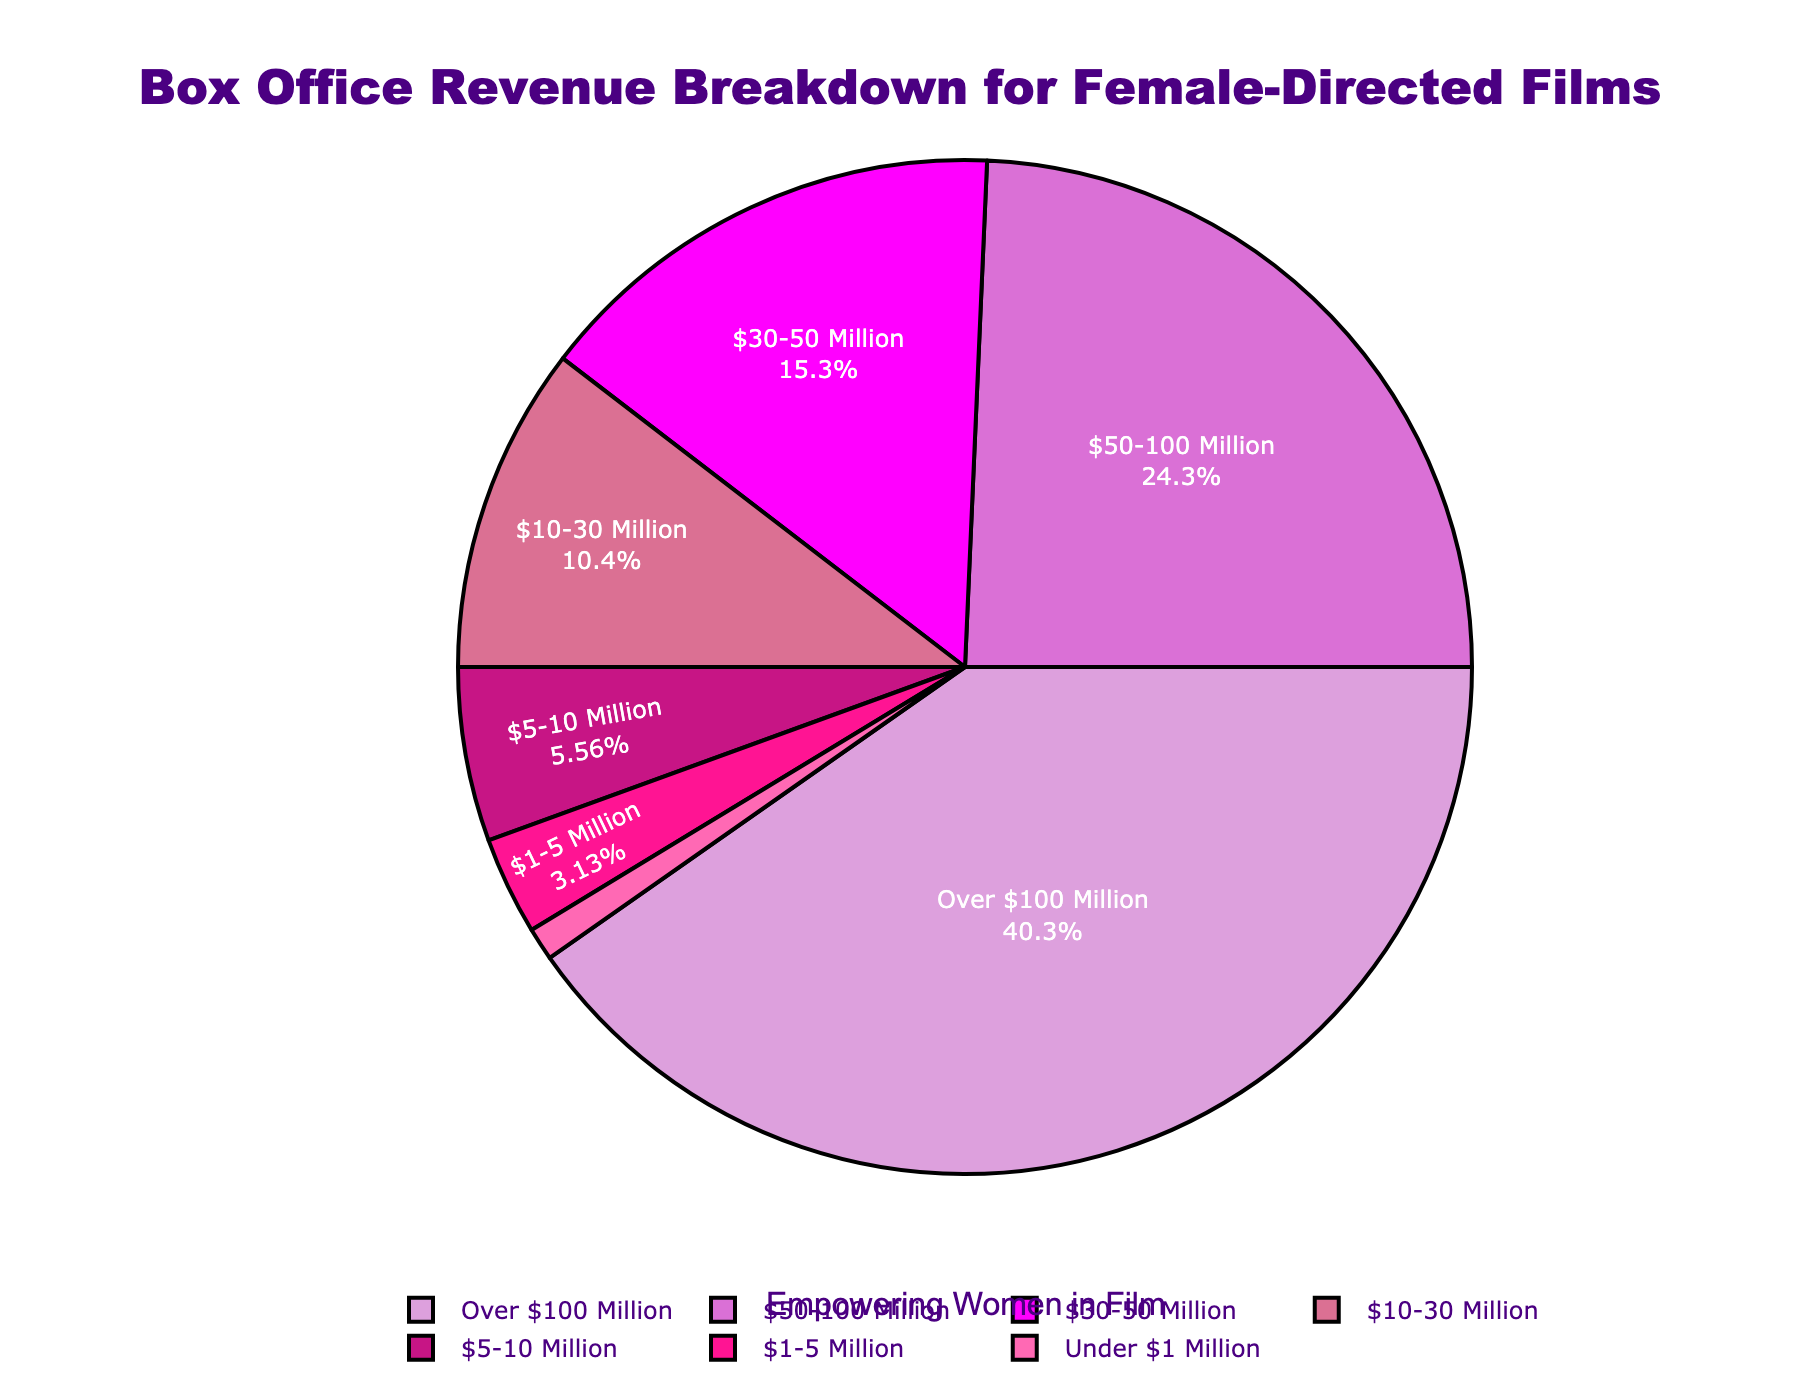What budget size category contributes the most to the box office revenue? According to the pie chart, the 'Over $100 Million' budget size category has the largest portion of the pie, indicating it contributes the most to the box office revenue.
Answer: Over $100 Million Which budget size category has the smallest box office revenue? The 'Under $1 Million' budget size category has the smallest section of the pie chart, indicating it has the least box office revenue.
Answer: Under $1 Million How much more revenue does the '$50-100 Million' category generate compared to the '$1-5 Million' category? The '$50-100 Million' category generates $350 Million, while the '$1-5 Million' category generates $45 Million. The difference is $350 Million - $45 Million = $305 Million.
Answer: $305 Million What is the total revenue for the budget categories under $10 Million? Total revenue for 'Under $1 Million' and '$1-5 Million' and '$5-10 Million' categories is $15 Million + $45 Million + $80 Million = $140 Million.
Answer: $140 Million What percentage of the total revenue is generated by the '$30-50 Million' budget category? The pie chart marks the percentages for each section. The '$30-50 Million' category occupies 220 Million out of the total 1440 Million, which is (220/1440)*100% = 15.28%.
Answer: 15.28% Is there a budget category that generates exactly one-third of the total revenue? Divide the total revenue by three, which is $1440 Million / 3 = $480 Million. No category on the chart generates exactly $480 Million, so the answer is no.
Answer: No Which two budget sizes combined make up more than half of the total revenue? The 'Over $100 Million' category contributes $580 Million. Adding the '$50-100 Million' category contributes another $350 Million, totaling $930 Million. This sum is more than half of the total revenue ($1440 Million).
Answer: Over $100 Million and $50-100 Million How many budget categories have a revenue greater than $100 Million? From the figure, the categories '$30-50 Million' ($220 Million), '$50-100 Million' ($350 Million), and 'Over $100 Million' ($580 Million) have revenues greater than $100 Million. This makes three categories in total.
Answer: Three What is the difference in percentage of revenue between the '$10-30 Million' and '$30-50 Million' categories? From the pie chart, calculate individual percentages for each: '$10-30 Million' ($150/1440*100%) = 10.42% and '$30-50 Million' ($220/1440*100%) = 15.28%. The difference is 15.28% - 10.42% = 4.86%.
Answer: 4.86% 